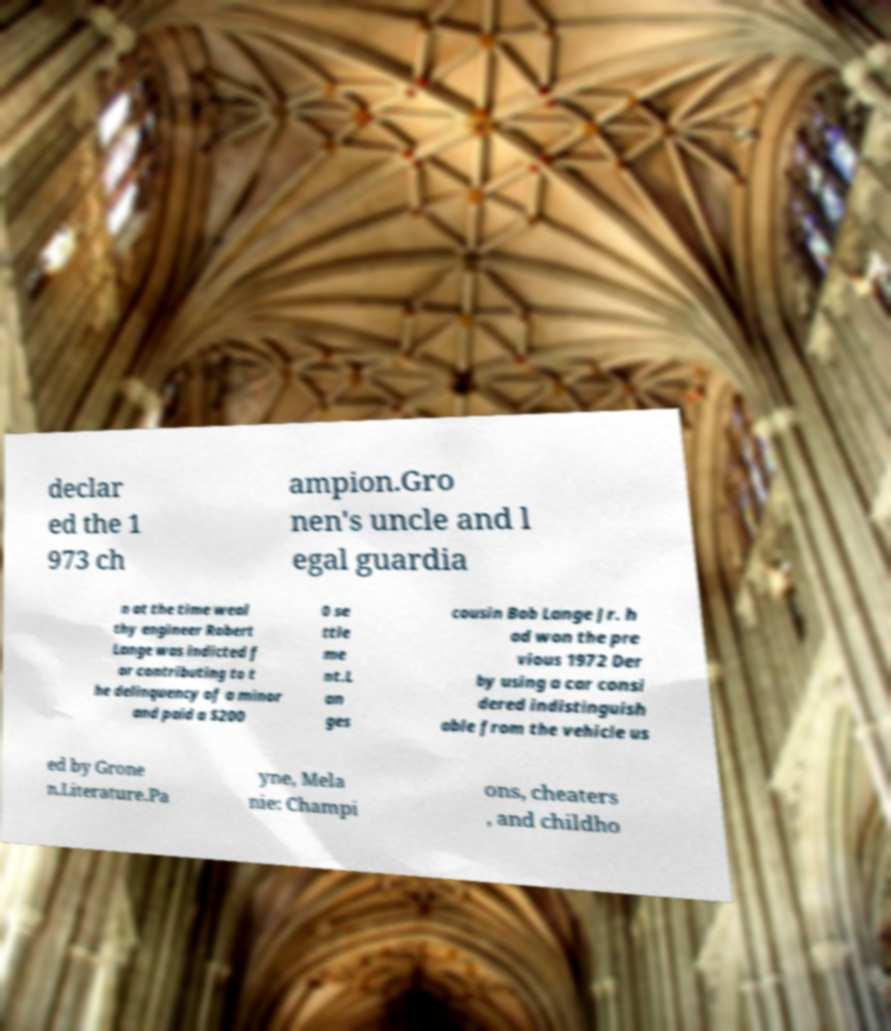For documentation purposes, I need the text within this image transcribed. Could you provide that? declar ed the 1 973 ch ampion.Gro nen's uncle and l egal guardia n at the time weal thy engineer Robert Lange was indicted f or contributing to t he delinquency of a minor and paid a $200 0 se ttle me nt.L an ges cousin Bob Lange Jr. h ad won the pre vious 1972 Der by using a car consi dered indistinguish able from the vehicle us ed by Grone n.Literature.Pa yne, Mela nie: Champi ons, cheaters , and childho 